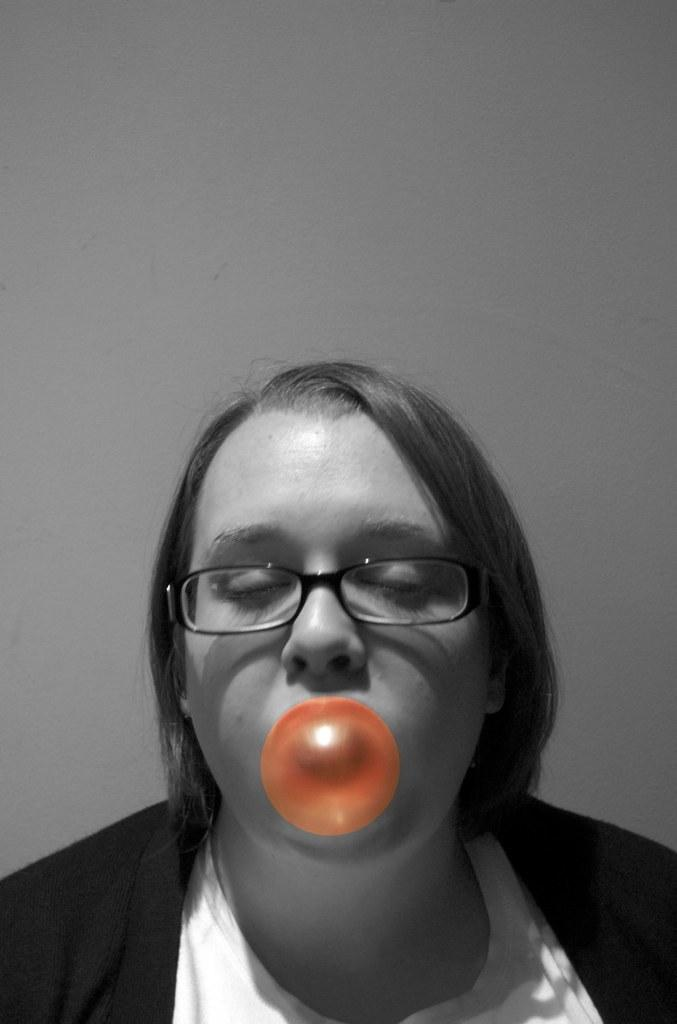Who is present in the image? There is a woman in the image. What is the woman doing in the image? The woman is blowing a bubble gum. What can be seen in the background of the image? There is a wall visible in the image. What type of toy can be seen on the dock in the image? There is no dock or toy present in the image. How many letters are visible on the wall in the image? There are no letters visible on the wall in the image. 